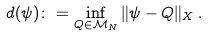Convert formula to latex. <formula><loc_0><loc_0><loc_500><loc_500>d ( \psi ) \colon = \inf _ { Q \in \mathcal { M } _ { N } } \| \psi - Q \| _ { X } \, .</formula> 